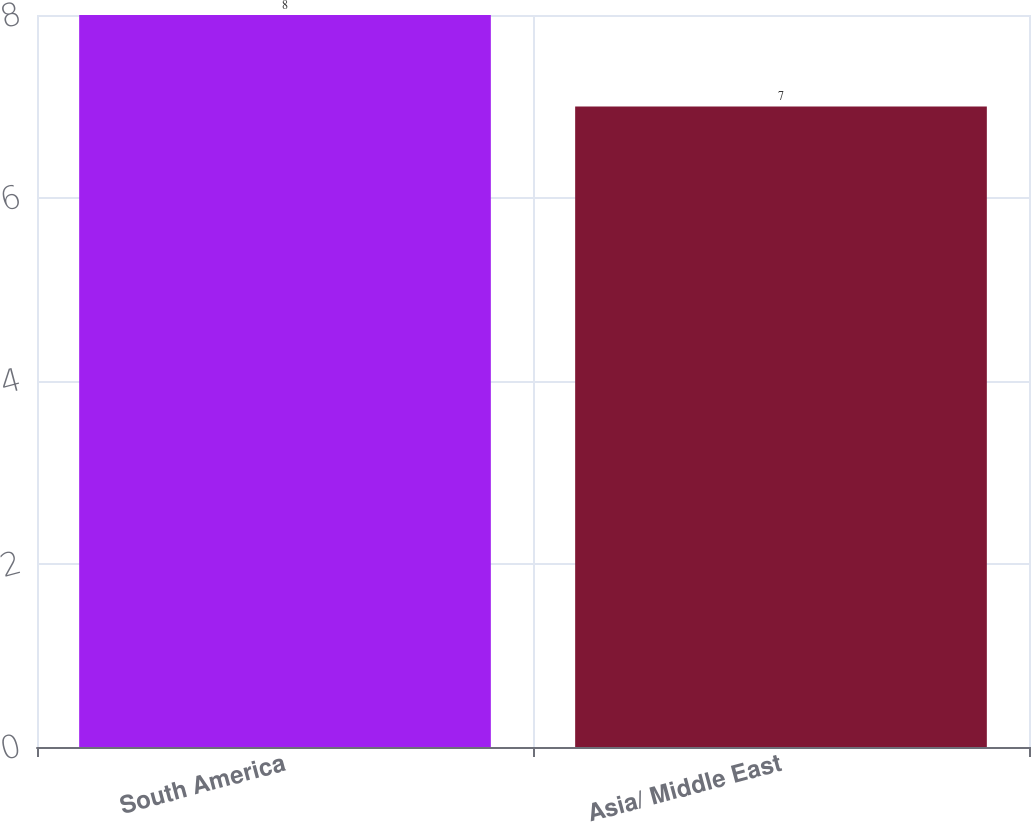<chart> <loc_0><loc_0><loc_500><loc_500><bar_chart><fcel>South America<fcel>Asia/ Middle East<nl><fcel>8<fcel>7<nl></chart> 